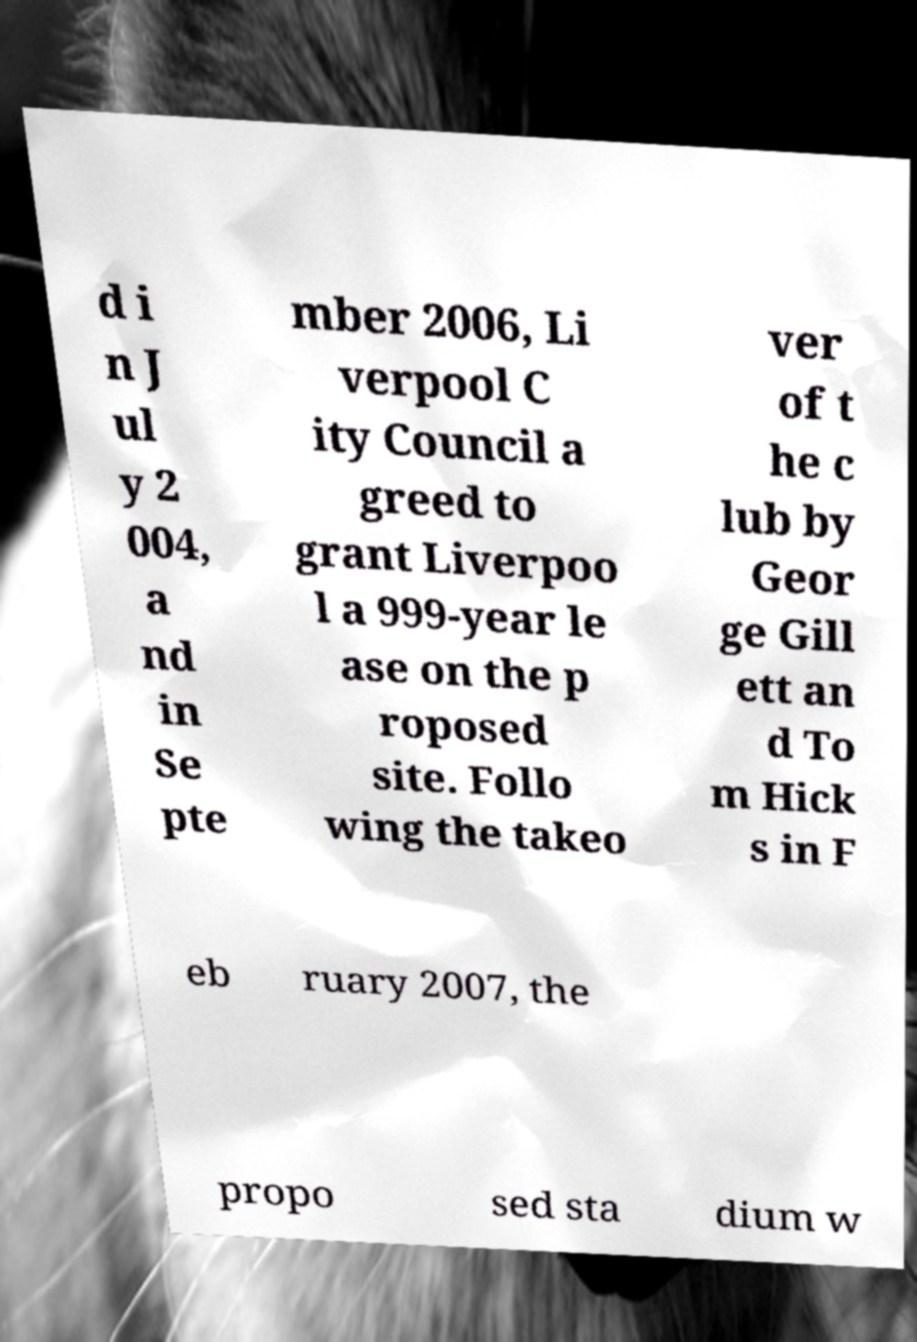Can you accurately transcribe the text from the provided image for me? d i n J ul y 2 004, a nd in Se pte mber 2006, Li verpool C ity Council a greed to grant Liverpoo l a 999-year le ase on the p roposed site. Follo wing the takeo ver of t he c lub by Geor ge Gill ett an d To m Hick s in F eb ruary 2007, the propo sed sta dium w 